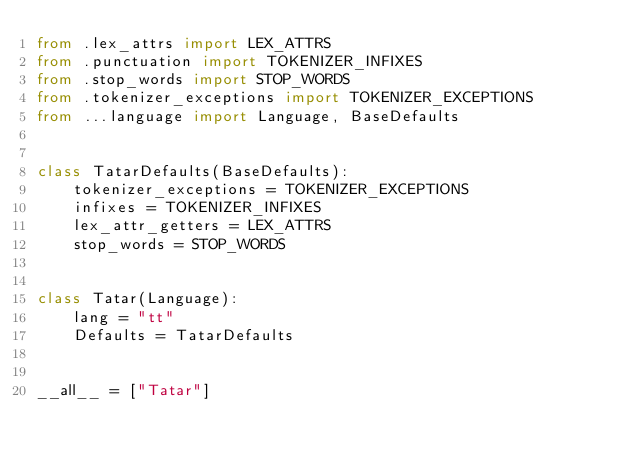Convert code to text. <code><loc_0><loc_0><loc_500><loc_500><_Python_>from .lex_attrs import LEX_ATTRS
from .punctuation import TOKENIZER_INFIXES
from .stop_words import STOP_WORDS
from .tokenizer_exceptions import TOKENIZER_EXCEPTIONS
from ...language import Language, BaseDefaults


class TatarDefaults(BaseDefaults):
    tokenizer_exceptions = TOKENIZER_EXCEPTIONS
    infixes = TOKENIZER_INFIXES
    lex_attr_getters = LEX_ATTRS
    stop_words = STOP_WORDS


class Tatar(Language):
    lang = "tt"
    Defaults = TatarDefaults


__all__ = ["Tatar"]
</code> 